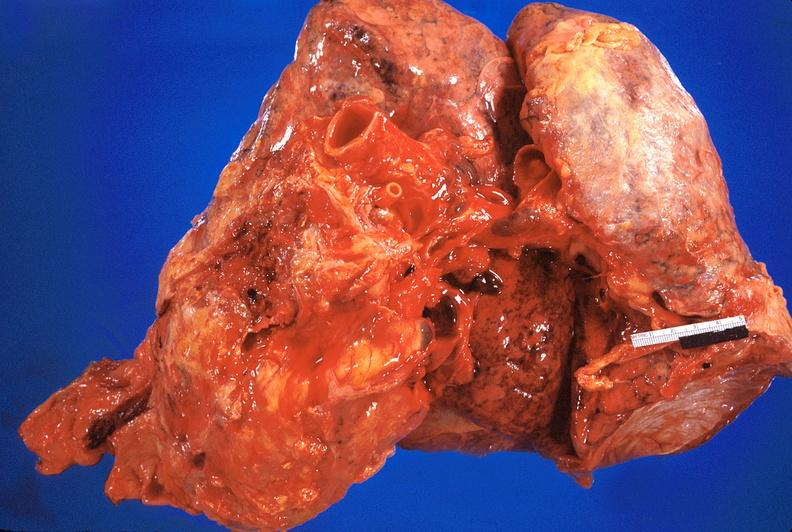where is this?
Answer the question using a single word or phrase. Heart 